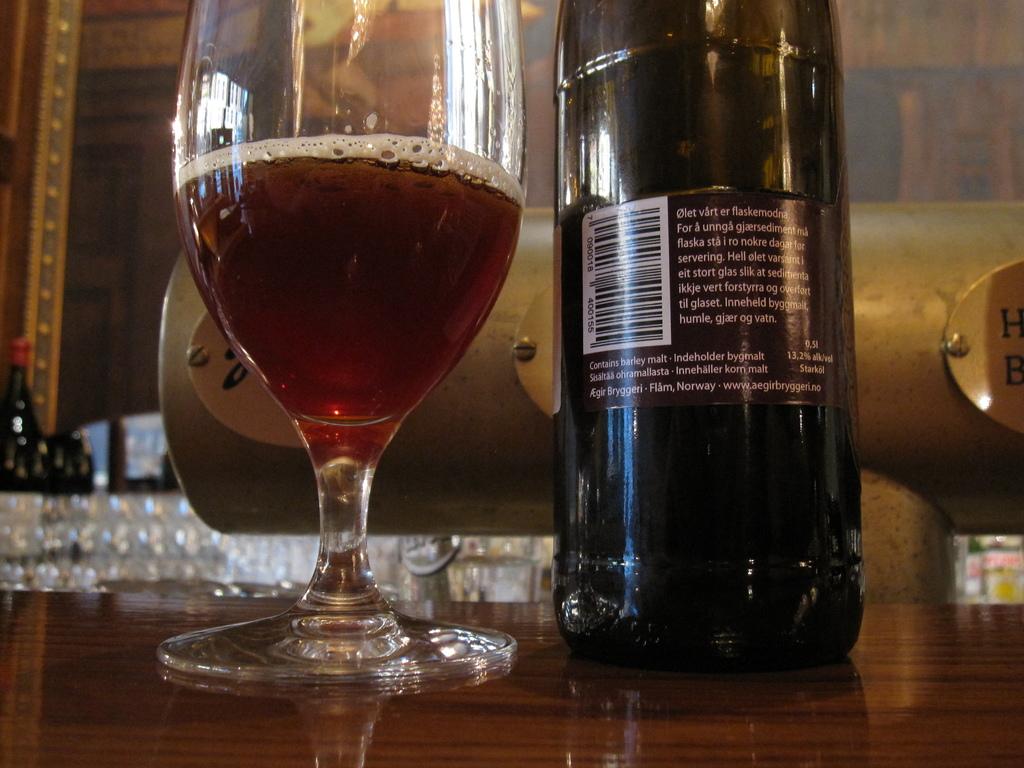What letters are visible on the gold plaque to the right?
Make the answer very short. H b. 